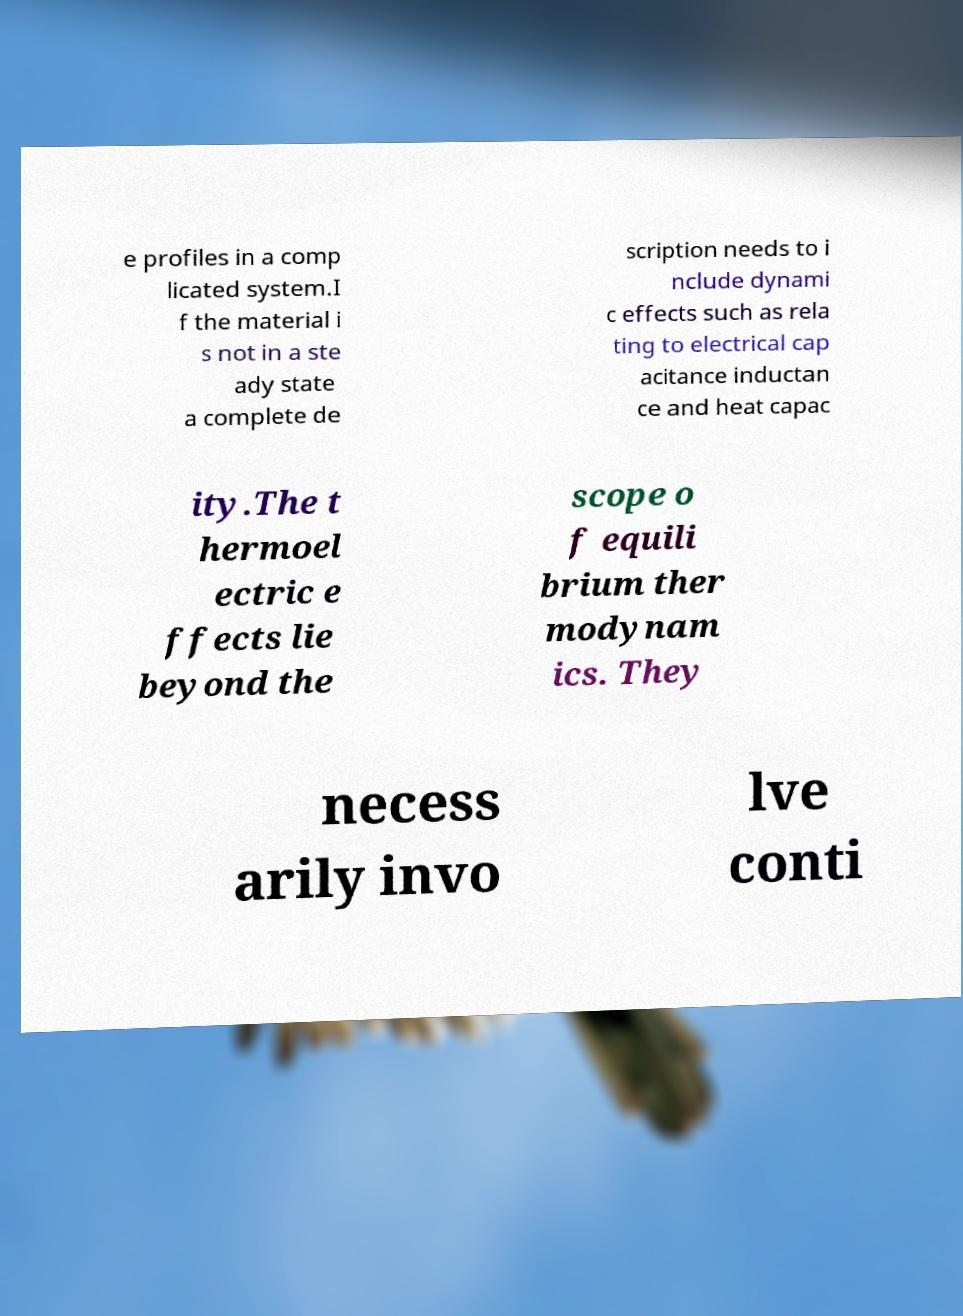For documentation purposes, I need the text within this image transcribed. Could you provide that? e profiles in a comp licated system.I f the material i s not in a ste ady state a complete de scription needs to i nclude dynami c effects such as rela ting to electrical cap acitance inductan ce and heat capac ity.The t hermoel ectric e ffects lie beyond the scope o f equili brium ther modynam ics. They necess arily invo lve conti 